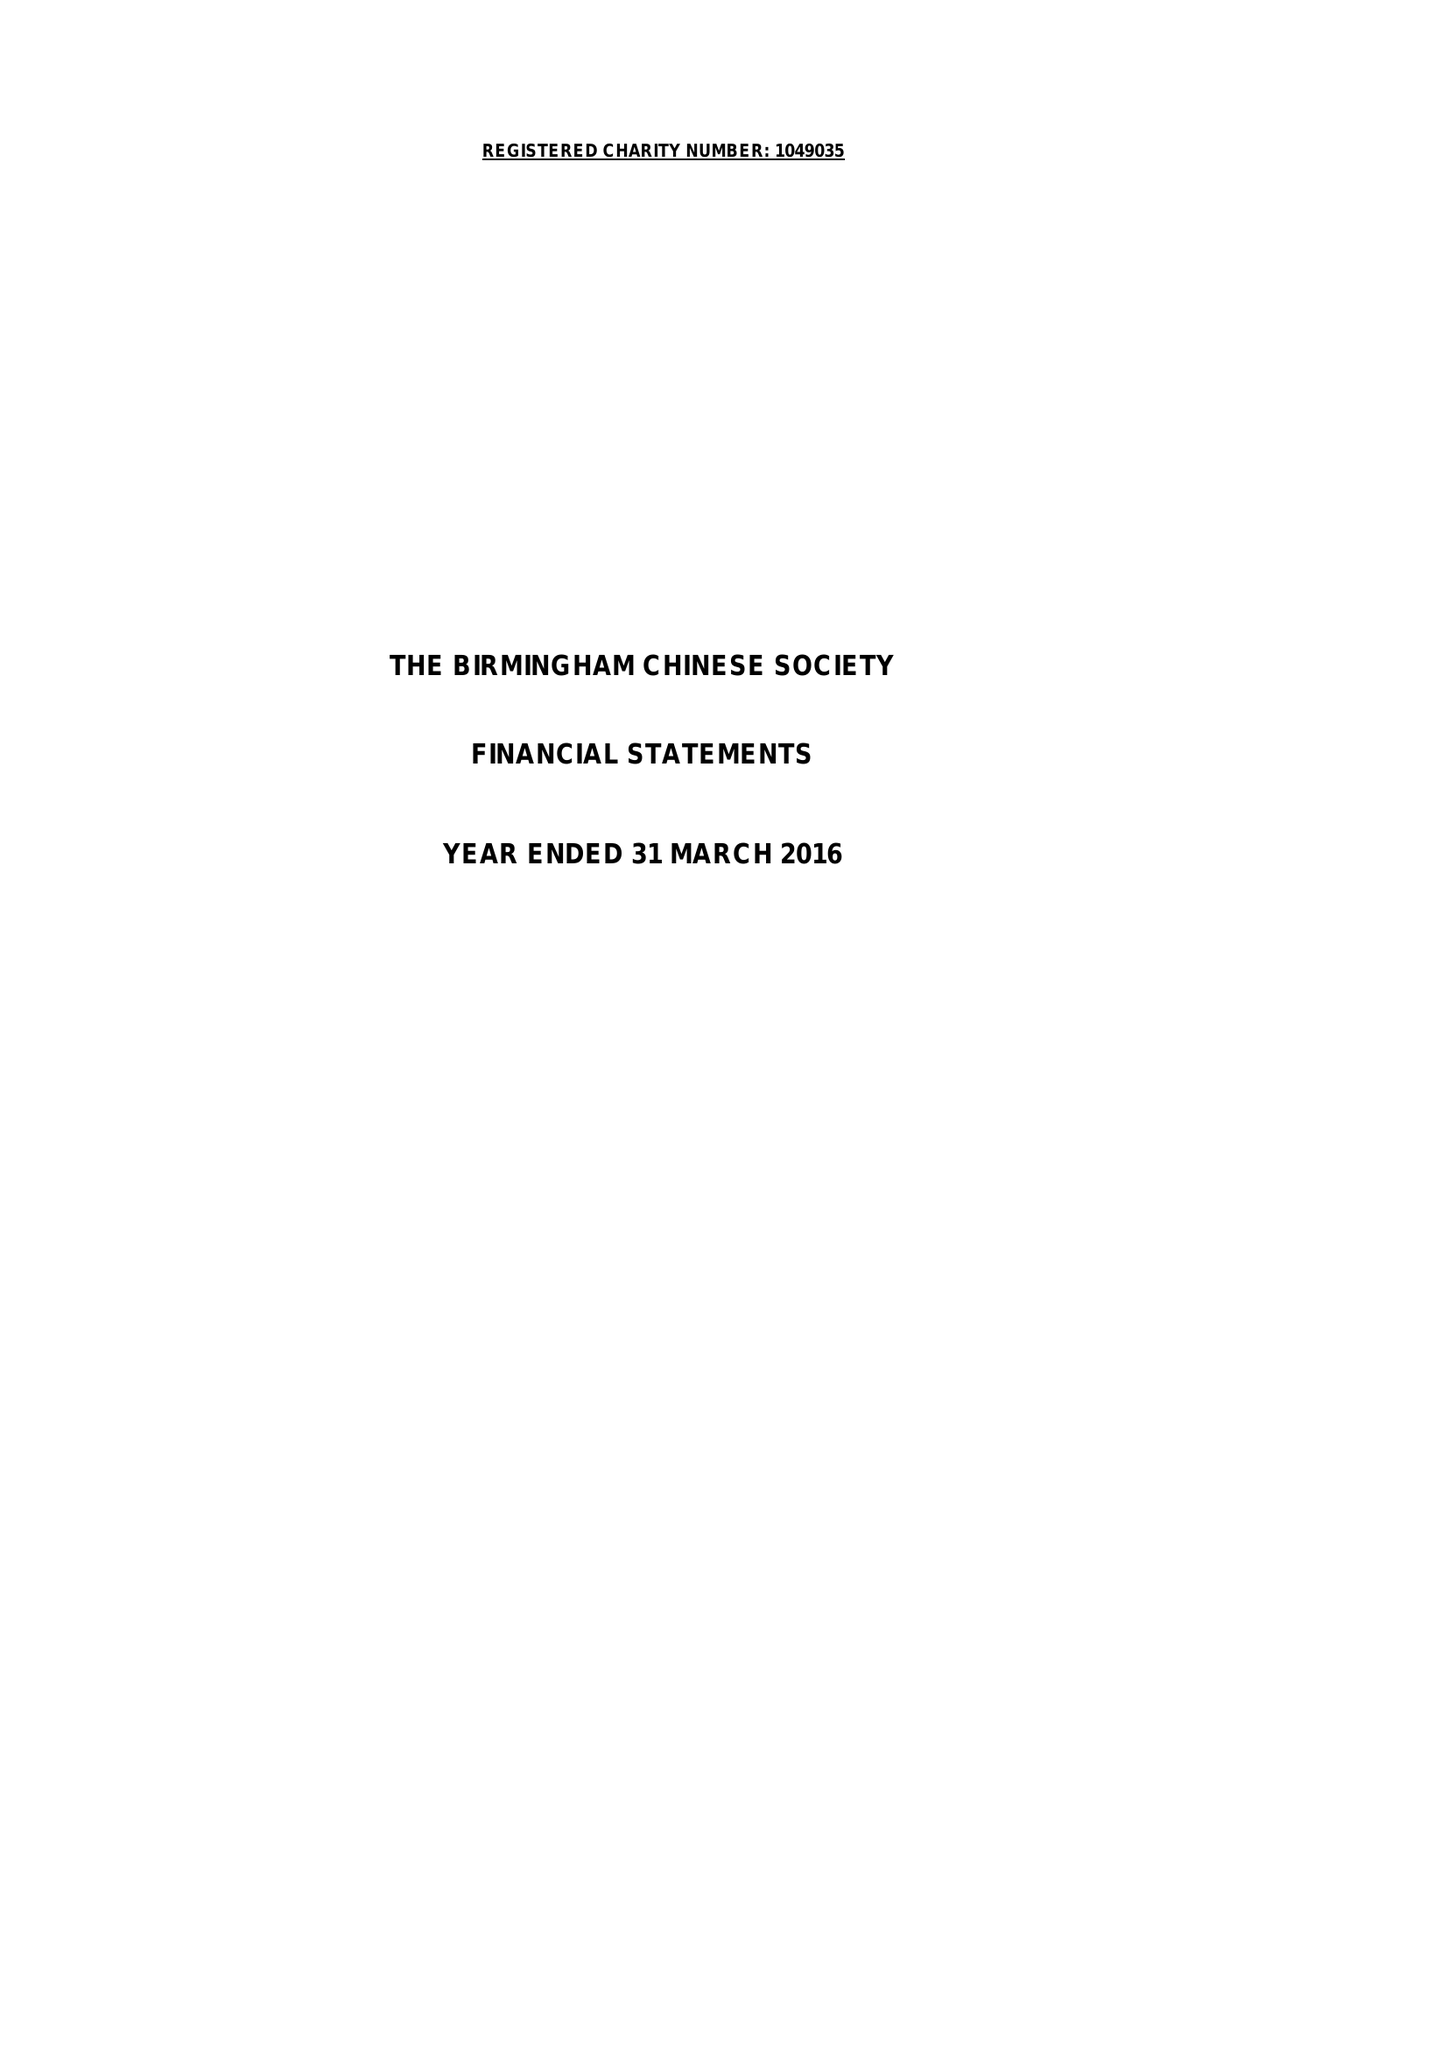What is the value for the address__postcode?
Answer the question using a single word or phrase. B9 4DY 